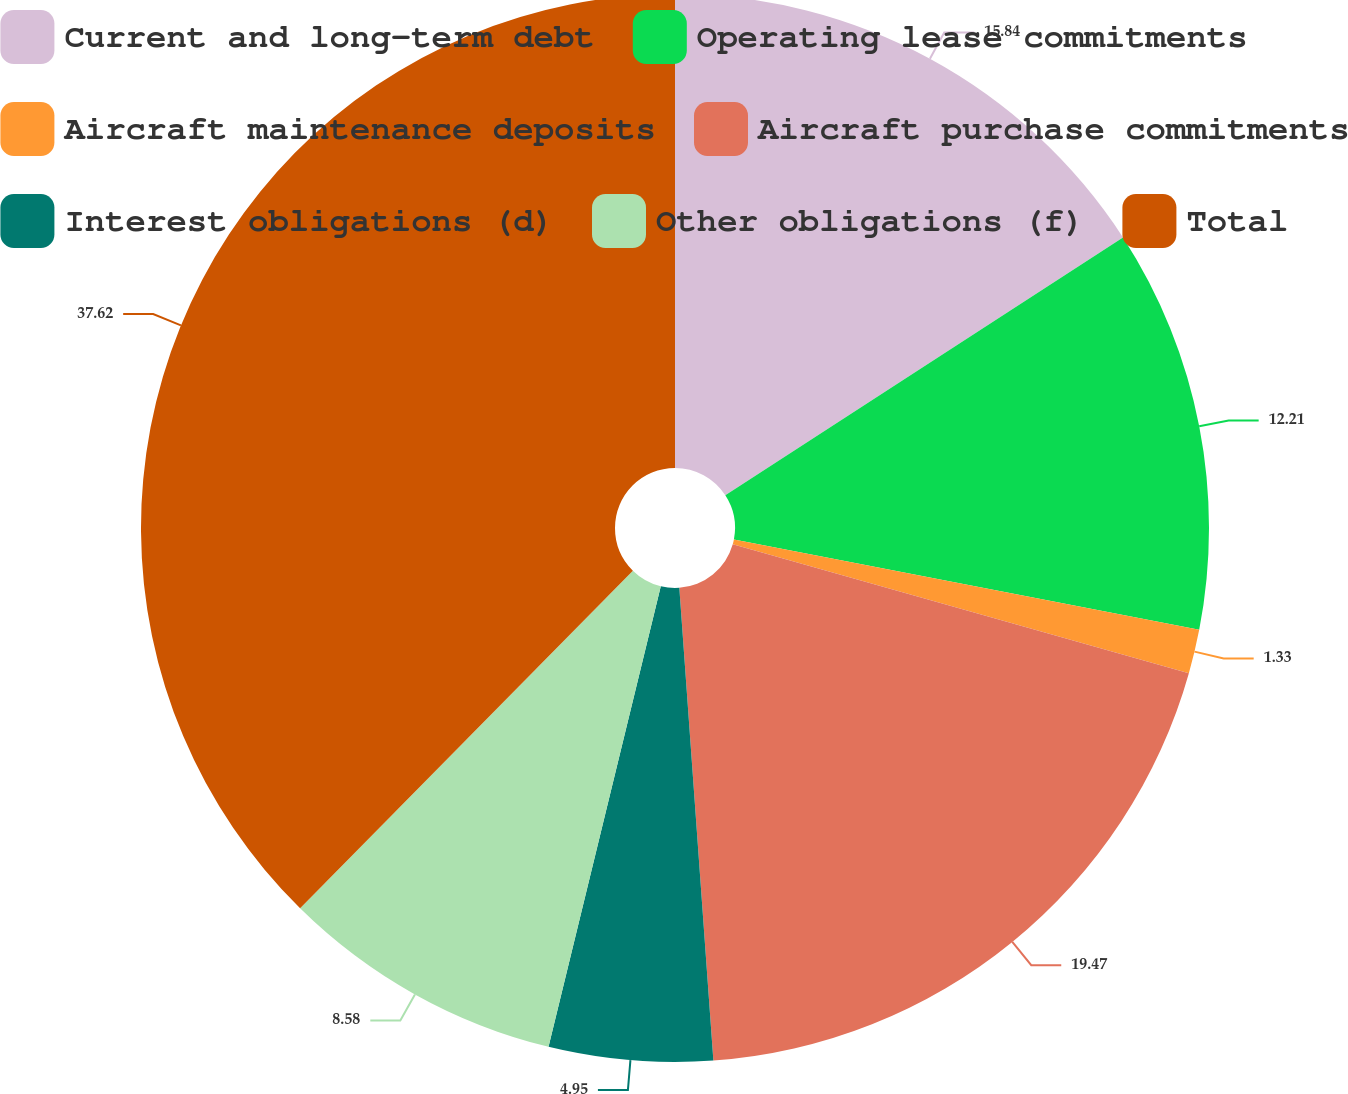Convert chart. <chart><loc_0><loc_0><loc_500><loc_500><pie_chart><fcel>Current and long-term debt<fcel>Operating lease commitments<fcel>Aircraft maintenance deposits<fcel>Aircraft purchase commitments<fcel>Interest obligations (d)<fcel>Other obligations (f)<fcel>Total<nl><fcel>15.84%<fcel>12.21%<fcel>1.33%<fcel>19.47%<fcel>4.95%<fcel>8.58%<fcel>37.61%<nl></chart> 